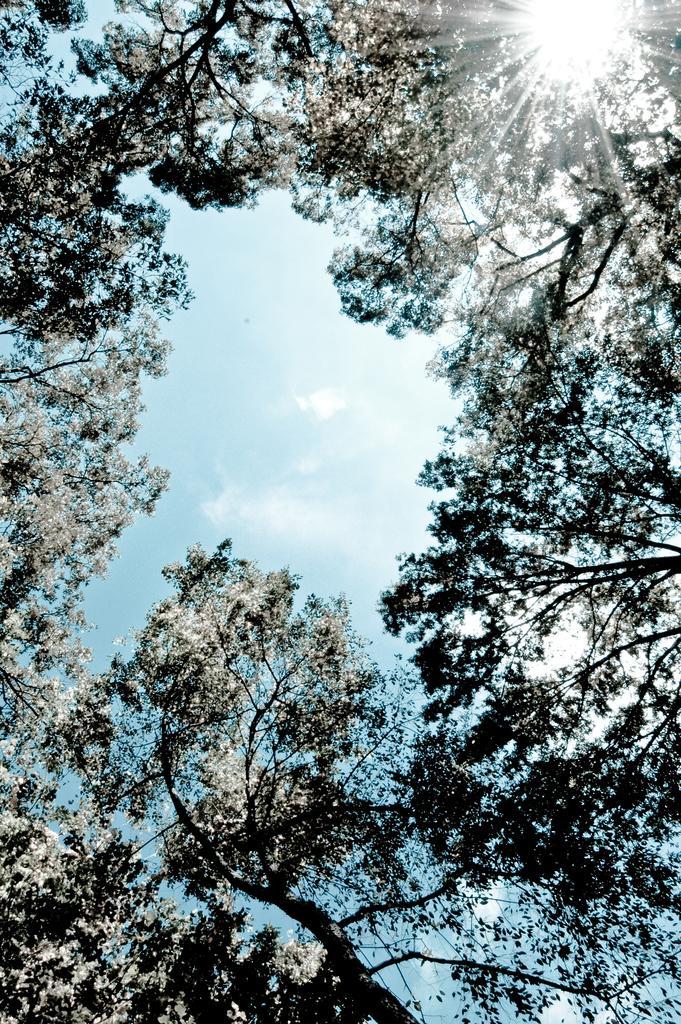In one or two sentences, can you explain what this image depicts? In this image we can see sky and trees. 